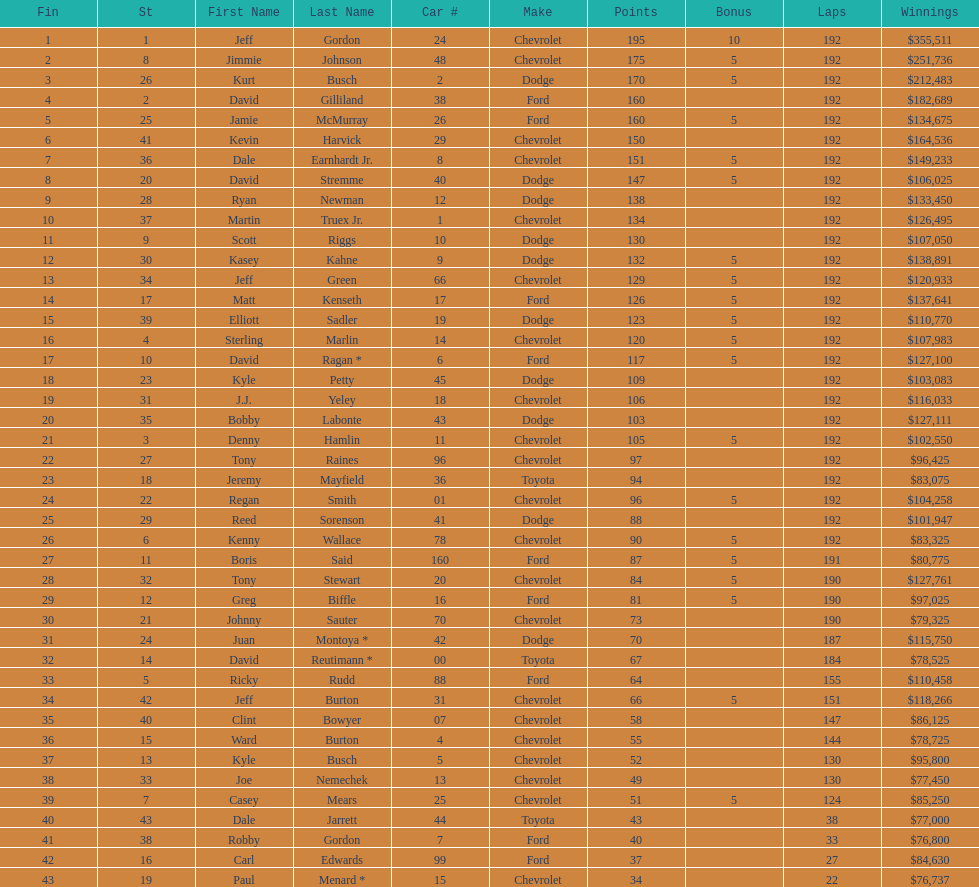How many drivers earned 5 bonus each in the race? 19. 